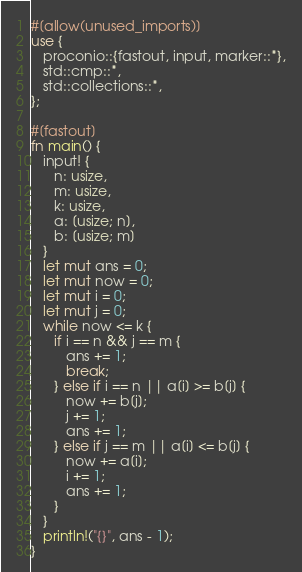Convert code to text. <code><loc_0><loc_0><loc_500><loc_500><_Rust_>#[allow(unused_imports)]
use {
   proconio::{fastout, input, marker::*},
   std::cmp::*,
   std::collections::*,
};

#[fastout]
fn main() {
   input! {
      n: usize,
      m: usize,
      k: usize,
      a: [usize; n],
      b: [usize; m]
   }
   let mut ans = 0;
   let mut now = 0;
   let mut i = 0;
   let mut j = 0;
   while now <= k {
      if i == n && j == m {
         ans += 1;
         break;
      } else if i == n || a[i] >= b[j] {
         now += b[j];
         j += 1;
         ans += 1;
      } else if j == m || a[i] <= b[j] {
         now += a[i];
         i += 1;
         ans += 1;
      }
   }
   println!("{}", ans - 1);
}
</code> 